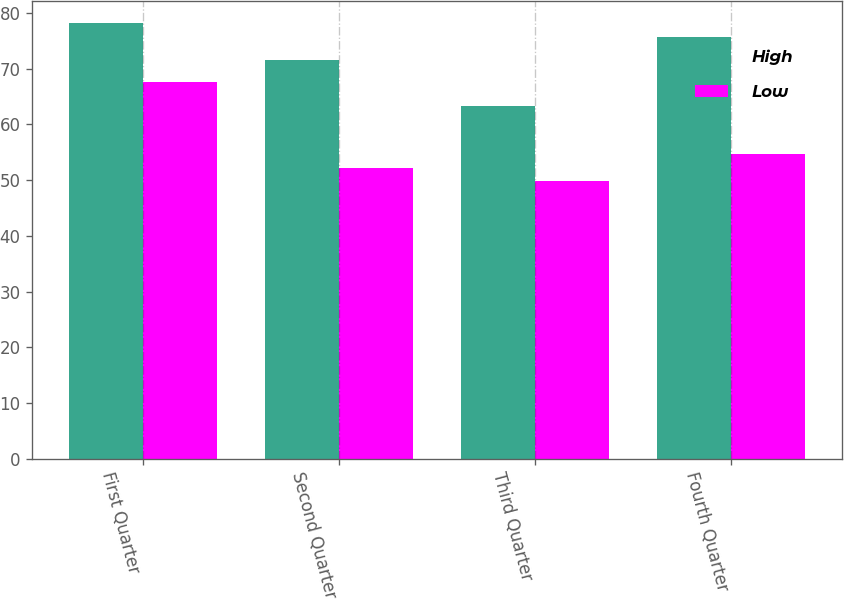Convert chart. <chart><loc_0><loc_0><loc_500><loc_500><stacked_bar_chart><ecel><fcel>First Quarter<fcel>Second Quarter<fcel>Third Quarter<fcel>Fourth Quarter<nl><fcel>High<fcel>78.25<fcel>71.53<fcel>63.4<fcel>75.64<nl><fcel>Low<fcel>67.7<fcel>52.09<fcel>49.87<fcel>54.76<nl></chart> 